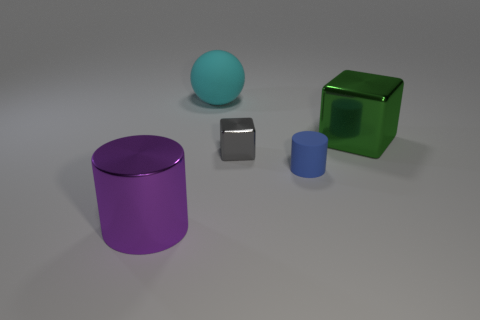There is a big purple cylinder; are there any big green blocks to the left of it?
Provide a succinct answer. No. Does the ball have the same material as the block in front of the green metallic thing?
Make the answer very short. No. Is the shape of the object that is behind the green object the same as  the tiny shiny thing?
Ensure brevity in your answer.  No. What number of other big purple things are the same material as the large purple thing?
Give a very brief answer. 0. What number of things are either large objects that are left of the tiny metal object or large brown rubber cylinders?
Your answer should be very brief. 2. The gray metal object has what size?
Your response must be concise. Small. There is a cube that is to the right of the cylinder that is right of the cyan matte object; what is it made of?
Ensure brevity in your answer.  Metal. There is a metal block that is in front of the green block; does it have the same size as the big purple cylinder?
Offer a very short reply. No. Is there a tiny rubber cylinder that has the same color as the shiny cylinder?
Your answer should be very brief. No. How many things are cylinders to the left of the small matte cylinder or things in front of the cyan ball?
Make the answer very short. 4. 